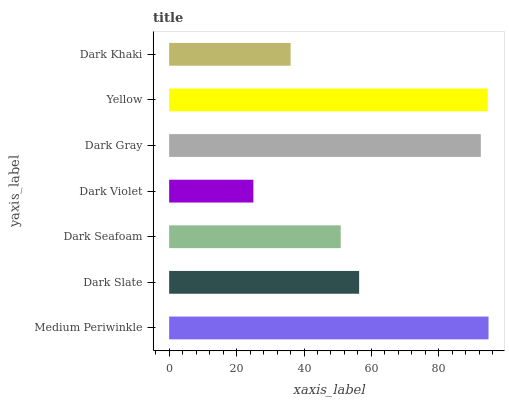Is Dark Violet the minimum?
Answer yes or no. Yes. Is Medium Periwinkle the maximum?
Answer yes or no. Yes. Is Dark Slate the minimum?
Answer yes or no. No. Is Dark Slate the maximum?
Answer yes or no. No. Is Medium Periwinkle greater than Dark Slate?
Answer yes or no. Yes. Is Dark Slate less than Medium Periwinkle?
Answer yes or no. Yes. Is Dark Slate greater than Medium Periwinkle?
Answer yes or no. No. Is Medium Periwinkle less than Dark Slate?
Answer yes or no. No. Is Dark Slate the high median?
Answer yes or no. Yes. Is Dark Slate the low median?
Answer yes or no. Yes. Is Dark Gray the high median?
Answer yes or no. No. Is Dark Violet the low median?
Answer yes or no. No. 